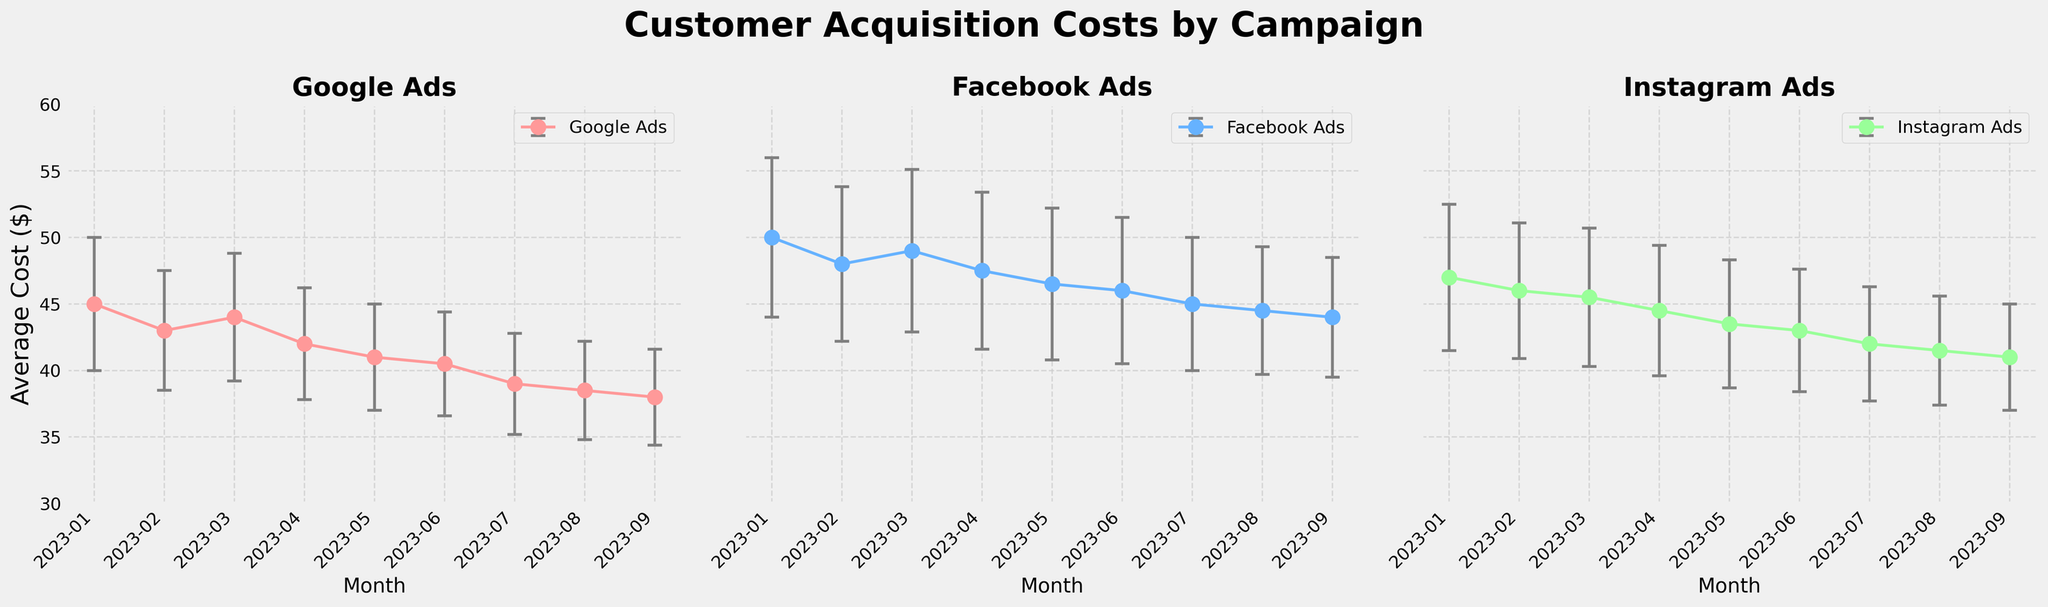What is the title of the figure? The title of the figure is located at the top and provides an overview of what the plot is about. By looking at the figure, one can see it reads "Customer Acquisition Costs by Campaign".
Answer: Customer Acquisition Costs by Campaign Which campaign has the lowest customer acquisition cost in August 2023? By examining the plot for August 2023, the markers represent the average customer acquisition cost for each campaign. The campaign with the lowest value in this month shows the lowest cost.
Answer: Google Ads What is the average customer acquisition cost in March 2023 for Instagram Ads? Locate the segment of the figure that represents Instagram Ads for March 2023. The marker shows the average cost directly. According to the data plot, it is $45.50.
Answer: $45.50 Among Google Ads, Facebook Ads, and Instagram Ads, which campaign shows a general decreasing trend in customer acquisition costs over the observed months? To determine this, track the trend in customer acquisition costs for each campaign from January to September. The campaign with consistent decreases represents a general decreasing trend.
Answer: Google Ads How does the variability (error bars) of Facebook Ads customer acquisition costs change from January to September 2023? Examine the length of the error bars for Facebook Ads from January to September. The variability can be interpreted by the length of these bars in each month and if it changes significantly.
Answer: Decreases What is the difference in average customer acquisition cost between Google Ads and Facebook Ads in July 2023? To find this, identify the markers for Google Ads and Facebook Ads in July 2023 and calculate the difference between the two average costs presented.
Answer: $6.00 Which campaign has the highest average customer acquisition cost in February 2023? Look at the markers for each campaign in February 2023. The one with the highest value indicates the highest average cost.
Answer: Facebook Ads Do any campaigns have overlapping error bars in September 2023? Check the error bars for all campaigns in September 2023. Overlapping error bars imply that the data ranges for different campaigns intersect at some point.
Answer: No What is the range of average customer acquisition costs for Google Ads across all months? To find the range, identify the highest and lowest average customer acquisition costs for Google Ads from January to September 2023 and calculate the difference between them.
Answer: $45.00 to $38.00 Which month shows the highest overall customer acquisition cost average across all campaigns? Calculate the average customer acquisition cost for each month by adding the average costs for all campaigns and comparing them month by month. Identify the month with the highest total average.
Answer: January 